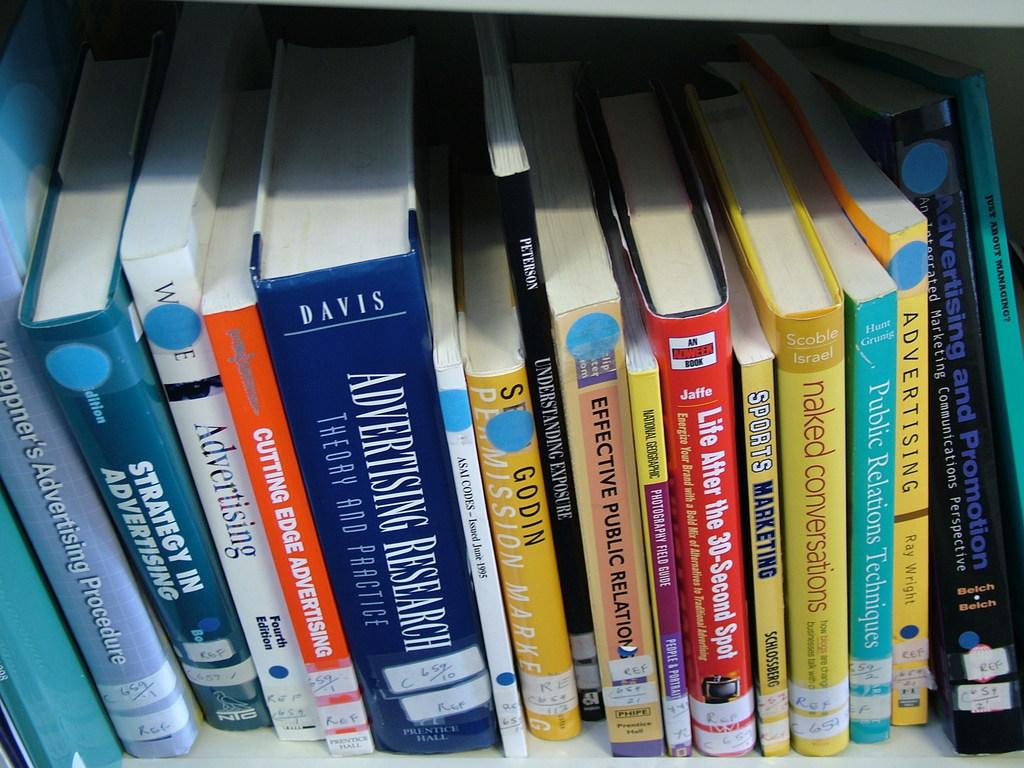Who wrote advertising research?
Offer a very short reply. Davis. What is the title of the book with the red spine?
Your answer should be very brief. Life after the 30 second spot. 